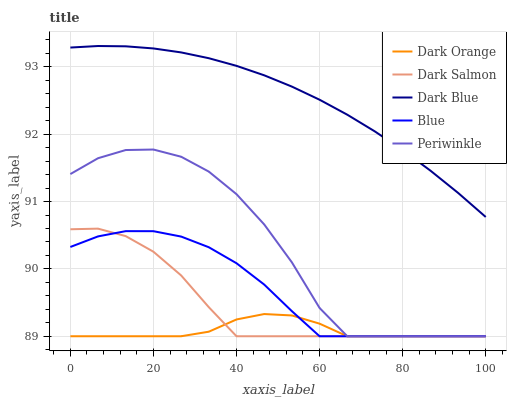Does Dark Orange have the minimum area under the curve?
Answer yes or no. Yes. Does Dark Blue have the maximum area under the curve?
Answer yes or no. Yes. Does Periwinkle have the minimum area under the curve?
Answer yes or no. No. Does Periwinkle have the maximum area under the curve?
Answer yes or no. No. Is Dark Blue the smoothest?
Answer yes or no. Yes. Is Periwinkle the roughest?
Answer yes or no. Yes. Is Dark Orange the smoothest?
Answer yes or no. No. Is Dark Orange the roughest?
Answer yes or no. No. Does Blue have the lowest value?
Answer yes or no. Yes. Does Dark Blue have the lowest value?
Answer yes or no. No. Does Dark Blue have the highest value?
Answer yes or no. Yes. Does Periwinkle have the highest value?
Answer yes or no. No. Is Blue less than Dark Blue?
Answer yes or no. Yes. Is Dark Blue greater than Dark Orange?
Answer yes or no. Yes. Does Dark Orange intersect Dark Salmon?
Answer yes or no. Yes. Is Dark Orange less than Dark Salmon?
Answer yes or no. No. Is Dark Orange greater than Dark Salmon?
Answer yes or no. No. Does Blue intersect Dark Blue?
Answer yes or no. No. 